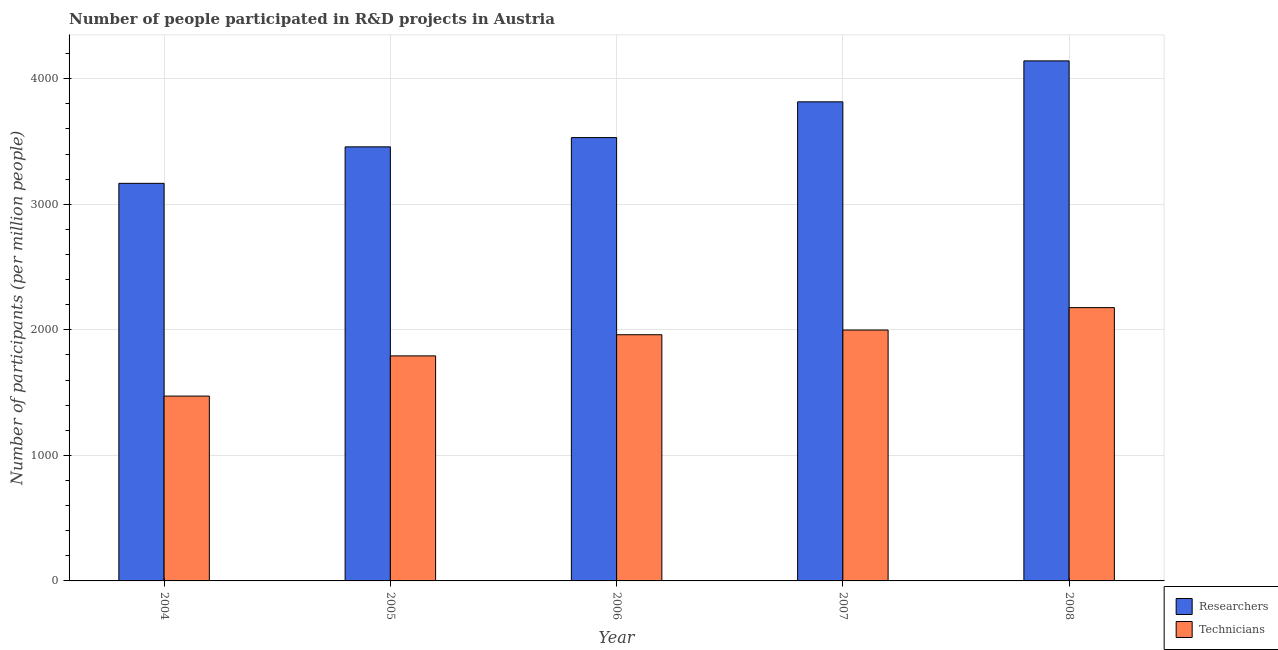How many bars are there on the 5th tick from the left?
Provide a succinct answer. 2. How many bars are there on the 3rd tick from the right?
Provide a succinct answer. 2. What is the number of researchers in 2004?
Your answer should be very brief. 3166.57. Across all years, what is the maximum number of technicians?
Give a very brief answer. 2176.7. Across all years, what is the minimum number of technicians?
Keep it short and to the point. 1472.18. In which year was the number of researchers minimum?
Offer a very short reply. 2004. What is the total number of technicians in the graph?
Ensure brevity in your answer.  9400.44. What is the difference between the number of technicians in 2005 and that in 2007?
Your response must be concise. -205.95. What is the difference between the number of technicians in 2005 and the number of researchers in 2007?
Your answer should be compact. -205.95. What is the average number of researchers per year?
Offer a very short reply. 3622.48. In the year 2008, what is the difference between the number of technicians and number of researchers?
Your answer should be compact. 0. What is the ratio of the number of researchers in 2004 to that in 2008?
Offer a very short reply. 0.76. Is the number of researchers in 2004 less than that in 2006?
Offer a terse response. Yes. Is the difference between the number of researchers in 2004 and 2007 greater than the difference between the number of technicians in 2004 and 2007?
Give a very brief answer. No. What is the difference between the highest and the second highest number of technicians?
Your response must be concise. 178.39. What is the difference between the highest and the lowest number of researchers?
Your answer should be very brief. 975.35. What does the 1st bar from the left in 2008 represents?
Make the answer very short. Researchers. What does the 1st bar from the right in 2005 represents?
Provide a short and direct response. Technicians. How many bars are there?
Make the answer very short. 10. Are all the bars in the graph horizontal?
Ensure brevity in your answer.  No. How many legend labels are there?
Offer a very short reply. 2. How are the legend labels stacked?
Make the answer very short. Vertical. What is the title of the graph?
Ensure brevity in your answer.  Number of people participated in R&D projects in Austria. Does "Urban Population" appear as one of the legend labels in the graph?
Provide a short and direct response. No. What is the label or title of the Y-axis?
Keep it short and to the point. Number of participants (per million people). What is the Number of participants (per million people) in Researchers in 2004?
Provide a succinct answer. 3166.57. What is the Number of participants (per million people) in Technicians in 2004?
Your response must be concise. 1472.18. What is the Number of participants (per million people) in Researchers in 2005?
Your answer should be very brief. 3457.21. What is the Number of participants (per million people) of Technicians in 2005?
Ensure brevity in your answer.  1792.36. What is the Number of participants (per million people) in Researchers in 2006?
Offer a very short reply. 3530.95. What is the Number of participants (per million people) in Technicians in 2006?
Offer a terse response. 1960.89. What is the Number of participants (per million people) of Researchers in 2007?
Ensure brevity in your answer.  3815.74. What is the Number of participants (per million people) of Technicians in 2007?
Your response must be concise. 1998.31. What is the Number of participants (per million people) in Researchers in 2008?
Offer a terse response. 4141.92. What is the Number of participants (per million people) of Technicians in 2008?
Offer a very short reply. 2176.7. Across all years, what is the maximum Number of participants (per million people) of Researchers?
Your response must be concise. 4141.92. Across all years, what is the maximum Number of participants (per million people) in Technicians?
Offer a very short reply. 2176.7. Across all years, what is the minimum Number of participants (per million people) in Researchers?
Your answer should be compact. 3166.57. Across all years, what is the minimum Number of participants (per million people) of Technicians?
Make the answer very short. 1472.18. What is the total Number of participants (per million people) of Researchers in the graph?
Your answer should be compact. 1.81e+04. What is the total Number of participants (per million people) in Technicians in the graph?
Give a very brief answer. 9400.44. What is the difference between the Number of participants (per million people) in Researchers in 2004 and that in 2005?
Your answer should be very brief. -290.63. What is the difference between the Number of participants (per million people) of Technicians in 2004 and that in 2005?
Offer a terse response. -320.18. What is the difference between the Number of participants (per million people) in Researchers in 2004 and that in 2006?
Provide a succinct answer. -364.37. What is the difference between the Number of participants (per million people) of Technicians in 2004 and that in 2006?
Offer a terse response. -488.71. What is the difference between the Number of participants (per million people) in Researchers in 2004 and that in 2007?
Ensure brevity in your answer.  -649.17. What is the difference between the Number of participants (per million people) of Technicians in 2004 and that in 2007?
Provide a succinct answer. -526.13. What is the difference between the Number of participants (per million people) of Researchers in 2004 and that in 2008?
Provide a short and direct response. -975.35. What is the difference between the Number of participants (per million people) in Technicians in 2004 and that in 2008?
Offer a very short reply. -704.53. What is the difference between the Number of participants (per million people) in Researchers in 2005 and that in 2006?
Provide a short and direct response. -73.74. What is the difference between the Number of participants (per million people) of Technicians in 2005 and that in 2006?
Make the answer very short. -168.53. What is the difference between the Number of participants (per million people) of Researchers in 2005 and that in 2007?
Make the answer very short. -358.54. What is the difference between the Number of participants (per million people) in Technicians in 2005 and that in 2007?
Offer a very short reply. -205.95. What is the difference between the Number of participants (per million people) of Researchers in 2005 and that in 2008?
Offer a very short reply. -684.72. What is the difference between the Number of participants (per million people) in Technicians in 2005 and that in 2008?
Offer a very short reply. -384.34. What is the difference between the Number of participants (per million people) of Researchers in 2006 and that in 2007?
Your answer should be compact. -284.8. What is the difference between the Number of participants (per million people) in Technicians in 2006 and that in 2007?
Give a very brief answer. -37.42. What is the difference between the Number of participants (per million people) in Researchers in 2006 and that in 2008?
Offer a very short reply. -610.98. What is the difference between the Number of participants (per million people) in Technicians in 2006 and that in 2008?
Provide a succinct answer. -215.82. What is the difference between the Number of participants (per million people) in Researchers in 2007 and that in 2008?
Keep it short and to the point. -326.18. What is the difference between the Number of participants (per million people) in Technicians in 2007 and that in 2008?
Offer a very short reply. -178.39. What is the difference between the Number of participants (per million people) in Researchers in 2004 and the Number of participants (per million people) in Technicians in 2005?
Provide a short and direct response. 1374.21. What is the difference between the Number of participants (per million people) in Researchers in 2004 and the Number of participants (per million people) in Technicians in 2006?
Offer a terse response. 1205.68. What is the difference between the Number of participants (per million people) in Researchers in 2004 and the Number of participants (per million people) in Technicians in 2007?
Your answer should be very brief. 1168.26. What is the difference between the Number of participants (per million people) in Researchers in 2004 and the Number of participants (per million people) in Technicians in 2008?
Offer a terse response. 989.87. What is the difference between the Number of participants (per million people) of Researchers in 2005 and the Number of participants (per million people) of Technicians in 2006?
Ensure brevity in your answer.  1496.32. What is the difference between the Number of participants (per million people) in Researchers in 2005 and the Number of participants (per million people) in Technicians in 2007?
Offer a terse response. 1458.9. What is the difference between the Number of participants (per million people) in Researchers in 2005 and the Number of participants (per million people) in Technicians in 2008?
Provide a succinct answer. 1280.5. What is the difference between the Number of participants (per million people) in Researchers in 2006 and the Number of participants (per million people) in Technicians in 2007?
Keep it short and to the point. 1532.63. What is the difference between the Number of participants (per million people) in Researchers in 2006 and the Number of participants (per million people) in Technicians in 2008?
Your answer should be very brief. 1354.24. What is the difference between the Number of participants (per million people) of Researchers in 2007 and the Number of participants (per million people) of Technicians in 2008?
Offer a terse response. 1639.04. What is the average Number of participants (per million people) of Researchers per year?
Provide a short and direct response. 3622.48. What is the average Number of participants (per million people) in Technicians per year?
Make the answer very short. 1880.09. In the year 2004, what is the difference between the Number of participants (per million people) in Researchers and Number of participants (per million people) in Technicians?
Offer a very short reply. 1694.39. In the year 2005, what is the difference between the Number of participants (per million people) in Researchers and Number of participants (per million people) in Technicians?
Make the answer very short. 1664.84. In the year 2006, what is the difference between the Number of participants (per million people) of Researchers and Number of participants (per million people) of Technicians?
Your answer should be compact. 1570.06. In the year 2007, what is the difference between the Number of participants (per million people) of Researchers and Number of participants (per million people) of Technicians?
Offer a very short reply. 1817.43. In the year 2008, what is the difference between the Number of participants (per million people) of Researchers and Number of participants (per million people) of Technicians?
Offer a very short reply. 1965.22. What is the ratio of the Number of participants (per million people) in Researchers in 2004 to that in 2005?
Make the answer very short. 0.92. What is the ratio of the Number of participants (per million people) of Technicians in 2004 to that in 2005?
Provide a succinct answer. 0.82. What is the ratio of the Number of participants (per million people) of Researchers in 2004 to that in 2006?
Ensure brevity in your answer.  0.9. What is the ratio of the Number of participants (per million people) in Technicians in 2004 to that in 2006?
Your answer should be compact. 0.75. What is the ratio of the Number of participants (per million people) in Researchers in 2004 to that in 2007?
Provide a succinct answer. 0.83. What is the ratio of the Number of participants (per million people) in Technicians in 2004 to that in 2007?
Your answer should be compact. 0.74. What is the ratio of the Number of participants (per million people) of Researchers in 2004 to that in 2008?
Offer a terse response. 0.76. What is the ratio of the Number of participants (per million people) of Technicians in 2004 to that in 2008?
Give a very brief answer. 0.68. What is the ratio of the Number of participants (per million people) of Researchers in 2005 to that in 2006?
Make the answer very short. 0.98. What is the ratio of the Number of participants (per million people) of Technicians in 2005 to that in 2006?
Give a very brief answer. 0.91. What is the ratio of the Number of participants (per million people) of Researchers in 2005 to that in 2007?
Offer a very short reply. 0.91. What is the ratio of the Number of participants (per million people) in Technicians in 2005 to that in 2007?
Keep it short and to the point. 0.9. What is the ratio of the Number of participants (per million people) in Researchers in 2005 to that in 2008?
Your answer should be very brief. 0.83. What is the ratio of the Number of participants (per million people) of Technicians in 2005 to that in 2008?
Your answer should be very brief. 0.82. What is the ratio of the Number of participants (per million people) of Researchers in 2006 to that in 2007?
Provide a short and direct response. 0.93. What is the ratio of the Number of participants (per million people) of Technicians in 2006 to that in 2007?
Your answer should be very brief. 0.98. What is the ratio of the Number of participants (per million people) of Researchers in 2006 to that in 2008?
Make the answer very short. 0.85. What is the ratio of the Number of participants (per million people) of Technicians in 2006 to that in 2008?
Your response must be concise. 0.9. What is the ratio of the Number of participants (per million people) in Researchers in 2007 to that in 2008?
Your response must be concise. 0.92. What is the ratio of the Number of participants (per million people) in Technicians in 2007 to that in 2008?
Make the answer very short. 0.92. What is the difference between the highest and the second highest Number of participants (per million people) of Researchers?
Make the answer very short. 326.18. What is the difference between the highest and the second highest Number of participants (per million people) in Technicians?
Make the answer very short. 178.39. What is the difference between the highest and the lowest Number of participants (per million people) in Researchers?
Offer a terse response. 975.35. What is the difference between the highest and the lowest Number of participants (per million people) in Technicians?
Provide a short and direct response. 704.53. 